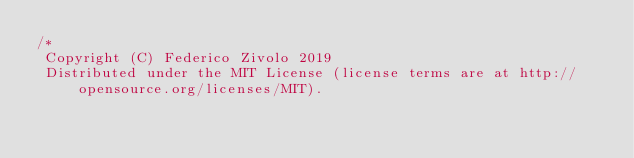Convert code to text. <code><loc_0><loc_0><loc_500><loc_500><_JavaScript_>/*
 Copyright (C) Federico Zivolo 2019
 Distributed under the MIT License (license terms are at http://opensource.org/licenses/MIT).</code> 